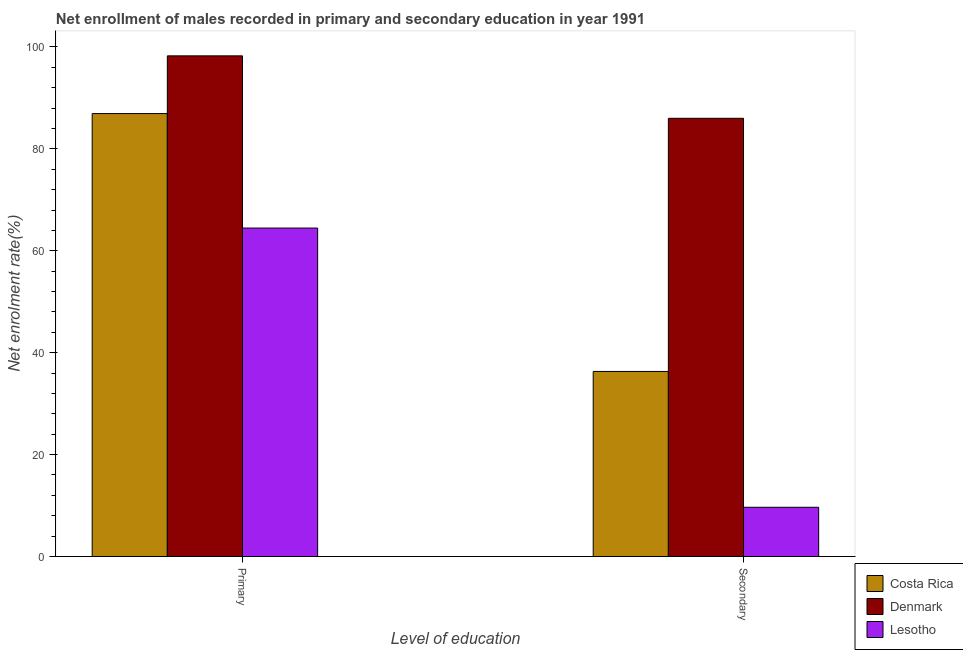How many different coloured bars are there?
Ensure brevity in your answer.  3. Are the number of bars per tick equal to the number of legend labels?
Keep it short and to the point. Yes. How many bars are there on the 1st tick from the right?
Give a very brief answer. 3. What is the label of the 1st group of bars from the left?
Ensure brevity in your answer.  Primary. What is the enrollment rate in secondary education in Lesotho?
Offer a very short reply. 9.67. Across all countries, what is the maximum enrollment rate in secondary education?
Provide a short and direct response. 86. Across all countries, what is the minimum enrollment rate in secondary education?
Offer a terse response. 9.67. In which country was the enrollment rate in secondary education minimum?
Your answer should be compact. Lesotho. What is the total enrollment rate in primary education in the graph?
Provide a short and direct response. 249.64. What is the difference between the enrollment rate in primary education in Denmark and that in Costa Rica?
Make the answer very short. 11.33. What is the difference between the enrollment rate in secondary education in Denmark and the enrollment rate in primary education in Costa Rica?
Offer a terse response. -0.93. What is the average enrollment rate in primary education per country?
Your response must be concise. 83.21. What is the difference between the enrollment rate in primary education and enrollment rate in secondary education in Denmark?
Give a very brief answer. 12.25. What is the ratio of the enrollment rate in secondary education in Lesotho to that in Costa Rica?
Make the answer very short. 0.27. Is the enrollment rate in secondary education in Costa Rica less than that in Lesotho?
Your answer should be compact. No. What does the 1st bar from the left in Primary represents?
Offer a terse response. Costa Rica. What does the 1st bar from the right in Primary represents?
Make the answer very short. Lesotho. How many bars are there?
Provide a succinct answer. 6. How many countries are there in the graph?
Your answer should be very brief. 3. Are the values on the major ticks of Y-axis written in scientific E-notation?
Provide a succinct answer. No. Does the graph contain grids?
Keep it short and to the point. No. Where does the legend appear in the graph?
Offer a terse response. Bottom right. How many legend labels are there?
Ensure brevity in your answer.  3. What is the title of the graph?
Give a very brief answer. Net enrollment of males recorded in primary and secondary education in year 1991. What is the label or title of the X-axis?
Ensure brevity in your answer.  Level of education. What is the label or title of the Y-axis?
Your answer should be compact. Net enrolment rate(%). What is the Net enrolment rate(%) of Costa Rica in Primary?
Your answer should be very brief. 86.93. What is the Net enrolment rate(%) in Denmark in Primary?
Provide a short and direct response. 98.25. What is the Net enrolment rate(%) in Lesotho in Primary?
Your response must be concise. 64.46. What is the Net enrolment rate(%) of Costa Rica in Secondary?
Provide a short and direct response. 36.32. What is the Net enrolment rate(%) in Denmark in Secondary?
Ensure brevity in your answer.  86. What is the Net enrolment rate(%) in Lesotho in Secondary?
Offer a terse response. 9.67. Across all Level of education, what is the maximum Net enrolment rate(%) in Costa Rica?
Make the answer very short. 86.93. Across all Level of education, what is the maximum Net enrolment rate(%) of Denmark?
Provide a succinct answer. 98.25. Across all Level of education, what is the maximum Net enrolment rate(%) of Lesotho?
Provide a short and direct response. 64.46. Across all Level of education, what is the minimum Net enrolment rate(%) in Costa Rica?
Keep it short and to the point. 36.32. Across all Level of education, what is the minimum Net enrolment rate(%) in Denmark?
Make the answer very short. 86. Across all Level of education, what is the minimum Net enrolment rate(%) of Lesotho?
Offer a very short reply. 9.67. What is the total Net enrolment rate(%) of Costa Rica in the graph?
Your answer should be very brief. 123.25. What is the total Net enrolment rate(%) of Denmark in the graph?
Your answer should be very brief. 184.25. What is the total Net enrolment rate(%) of Lesotho in the graph?
Your response must be concise. 74.12. What is the difference between the Net enrolment rate(%) in Costa Rica in Primary and that in Secondary?
Keep it short and to the point. 50.61. What is the difference between the Net enrolment rate(%) in Denmark in Primary and that in Secondary?
Your response must be concise. 12.25. What is the difference between the Net enrolment rate(%) of Lesotho in Primary and that in Secondary?
Provide a succinct answer. 54.79. What is the difference between the Net enrolment rate(%) in Costa Rica in Primary and the Net enrolment rate(%) in Denmark in Secondary?
Ensure brevity in your answer.  0.93. What is the difference between the Net enrolment rate(%) in Costa Rica in Primary and the Net enrolment rate(%) in Lesotho in Secondary?
Give a very brief answer. 77.26. What is the difference between the Net enrolment rate(%) of Denmark in Primary and the Net enrolment rate(%) of Lesotho in Secondary?
Provide a short and direct response. 88.59. What is the average Net enrolment rate(%) in Costa Rica per Level of education?
Your response must be concise. 61.62. What is the average Net enrolment rate(%) of Denmark per Level of education?
Give a very brief answer. 92.12. What is the average Net enrolment rate(%) in Lesotho per Level of education?
Offer a very short reply. 37.06. What is the difference between the Net enrolment rate(%) in Costa Rica and Net enrolment rate(%) in Denmark in Primary?
Provide a succinct answer. -11.33. What is the difference between the Net enrolment rate(%) in Costa Rica and Net enrolment rate(%) in Lesotho in Primary?
Your answer should be very brief. 22.47. What is the difference between the Net enrolment rate(%) of Denmark and Net enrolment rate(%) of Lesotho in Primary?
Give a very brief answer. 33.79. What is the difference between the Net enrolment rate(%) in Costa Rica and Net enrolment rate(%) in Denmark in Secondary?
Ensure brevity in your answer.  -49.68. What is the difference between the Net enrolment rate(%) in Costa Rica and Net enrolment rate(%) in Lesotho in Secondary?
Offer a very short reply. 26.66. What is the difference between the Net enrolment rate(%) of Denmark and Net enrolment rate(%) of Lesotho in Secondary?
Offer a terse response. 76.33. What is the ratio of the Net enrolment rate(%) of Costa Rica in Primary to that in Secondary?
Give a very brief answer. 2.39. What is the ratio of the Net enrolment rate(%) of Denmark in Primary to that in Secondary?
Give a very brief answer. 1.14. What is the ratio of the Net enrolment rate(%) in Lesotho in Primary to that in Secondary?
Make the answer very short. 6.67. What is the difference between the highest and the second highest Net enrolment rate(%) in Costa Rica?
Ensure brevity in your answer.  50.61. What is the difference between the highest and the second highest Net enrolment rate(%) of Denmark?
Make the answer very short. 12.25. What is the difference between the highest and the second highest Net enrolment rate(%) in Lesotho?
Provide a succinct answer. 54.79. What is the difference between the highest and the lowest Net enrolment rate(%) of Costa Rica?
Offer a very short reply. 50.61. What is the difference between the highest and the lowest Net enrolment rate(%) of Denmark?
Give a very brief answer. 12.25. What is the difference between the highest and the lowest Net enrolment rate(%) in Lesotho?
Provide a short and direct response. 54.79. 